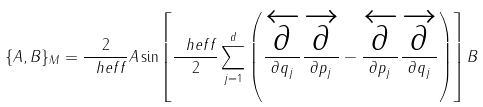<formula> <loc_0><loc_0><loc_500><loc_500>\{ A , B \} _ { M } = \frac { 2 } { \ h e f f } A \sin \left [ \frac { \ h e f f } { 2 } \sum _ { j = 1 } ^ { d } \left ( \frac { \overleftarrow { \partial } } { \partial q _ { j } } \frac { \overrightarrow { \partial } } { \partial p _ { j } } - \frac { \overleftarrow { \partial } } { \partial p _ { j } } \frac { \overrightarrow { \partial } } { \partial q _ { j } } \right ) \right ] B</formula> 